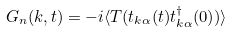Convert formula to latex. <formula><loc_0><loc_0><loc_500><loc_500>G _ { n } ( { k } , t ) = - i \langle T ( t _ { { k } \alpha } ( t ) t ^ { \dagger } _ { { k } \alpha } ( 0 ) ) \rangle</formula> 